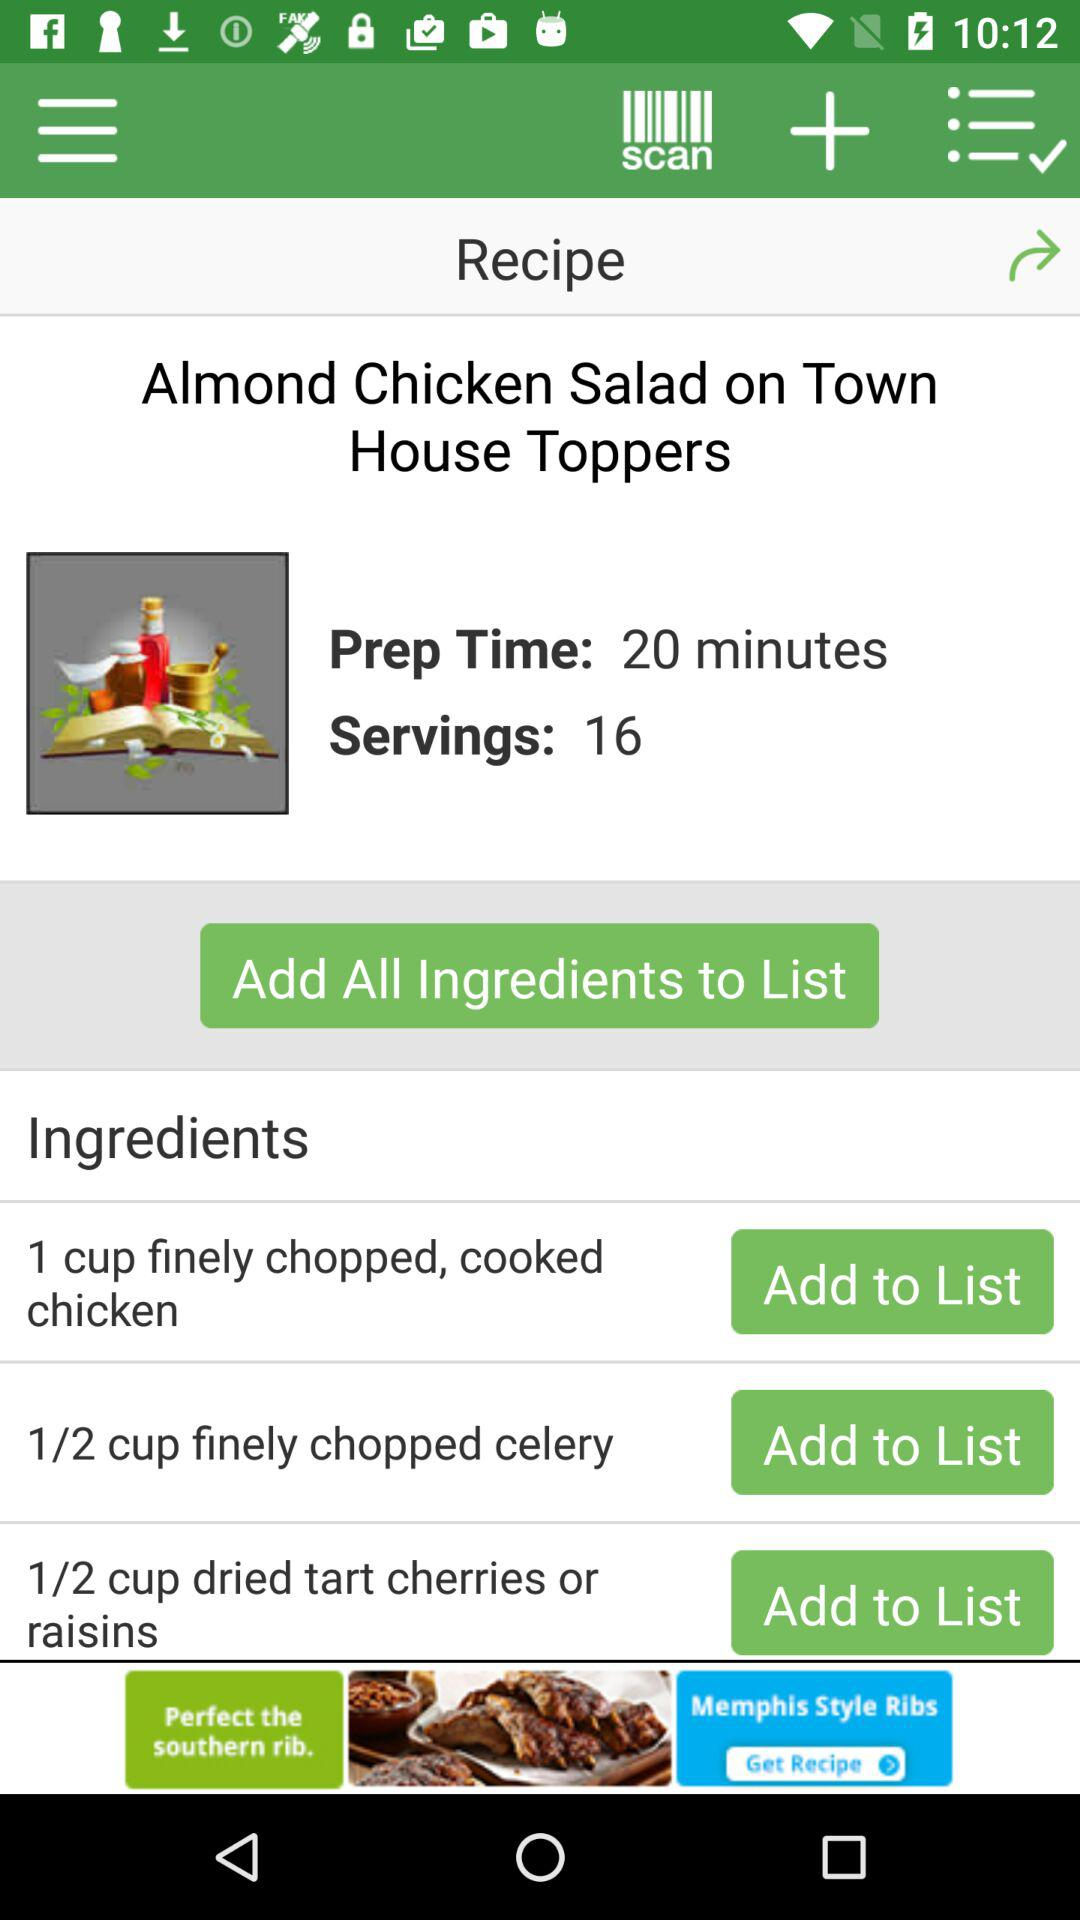What is the preparation time for "Almond Chicken Salad"? The preparation time for "Almond Chicken Salad" is 20 minutes. 